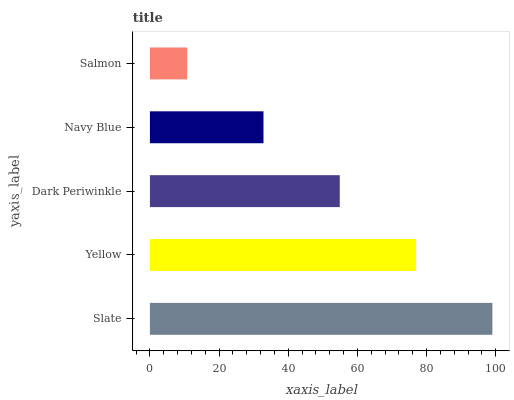Is Salmon the minimum?
Answer yes or no. Yes. Is Slate the maximum?
Answer yes or no. Yes. Is Yellow the minimum?
Answer yes or no. No. Is Yellow the maximum?
Answer yes or no. No. Is Slate greater than Yellow?
Answer yes or no. Yes. Is Yellow less than Slate?
Answer yes or no. Yes. Is Yellow greater than Slate?
Answer yes or no. No. Is Slate less than Yellow?
Answer yes or no. No. Is Dark Periwinkle the high median?
Answer yes or no. Yes. Is Dark Periwinkle the low median?
Answer yes or no. Yes. Is Slate the high median?
Answer yes or no. No. Is Navy Blue the low median?
Answer yes or no. No. 